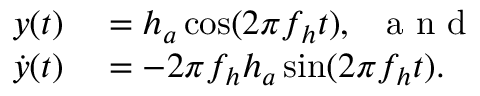Convert formula to latex. <formula><loc_0><loc_0><loc_500><loc_500>\begin{array} { r l } { { y } ( { t } ) } & = h _ { a } \cos ( 2 \pi f _ { h } { t } ) , \, a n d } \\ { \dot { y } ( { t } ) } & = - 2 \pi f _ { h } h _ { a } \sin ( 2 \pi f _ { h } { t } ) . } \end{array}</formula> 